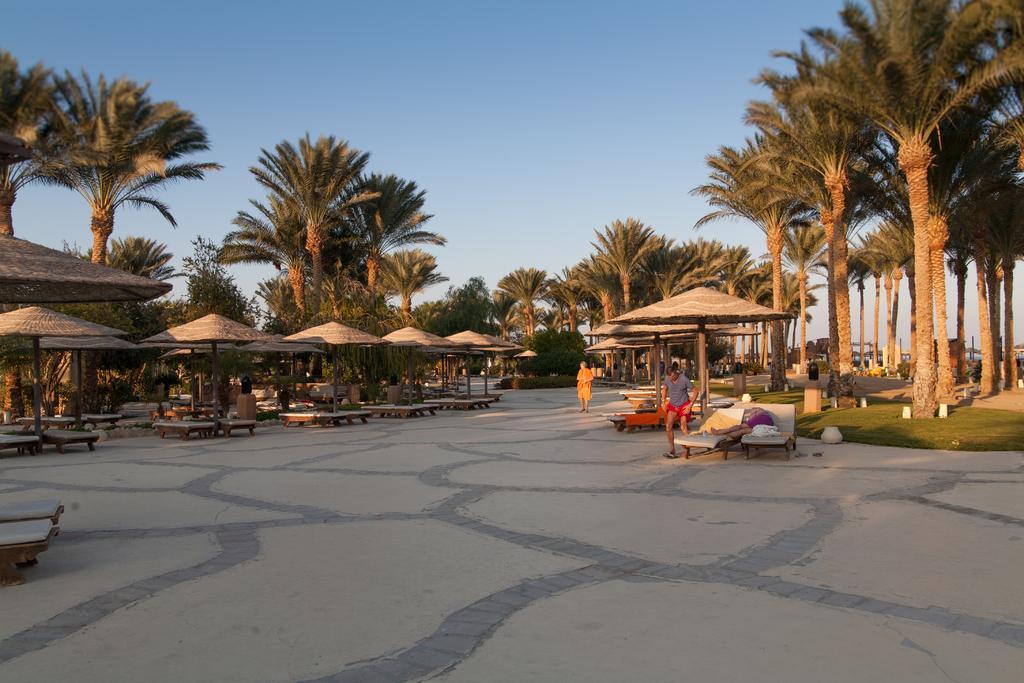Describe this image in one or two sentences. In this image we can see tents with benches. Also there are few people. There are many trees. On the ground there is grass. In the background there is sky. 